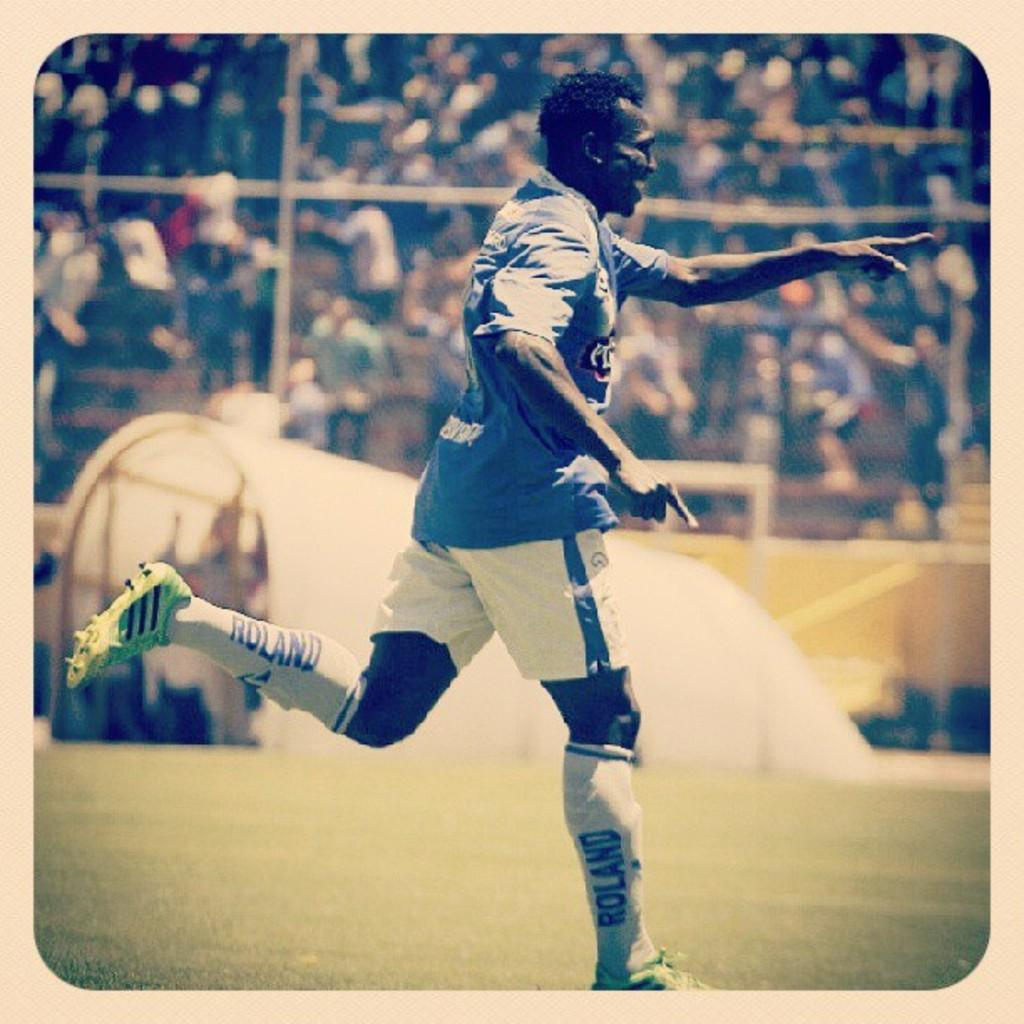What is the person in the image doing? The person is running in the image. Where is the person running? The person is running on a grass field. What can be seen in the background of the image? There is a fence and a group of audience in the background of the image. What type of hose is being used by the person running in the image? There is no hose present in the image; the person is simply running on a grass field. 